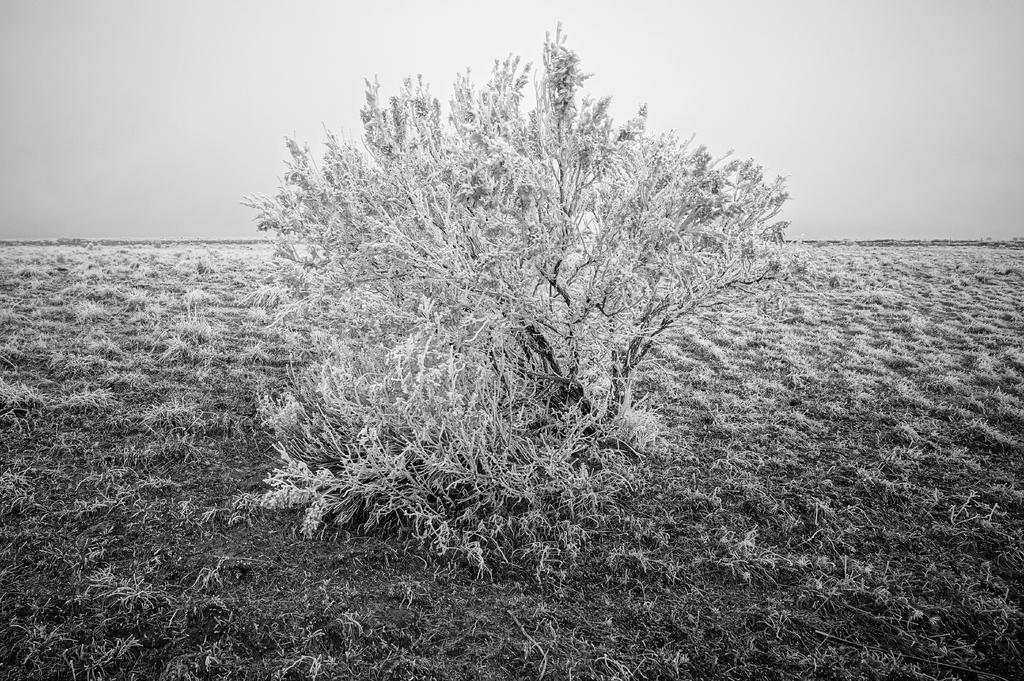Could you give a brief overview of what you see in this image? This image is a black and white image. This image is taken outdoors. At the top of the image there is the sky. At the bottom of the image there is ground with grass on it. In the middle of the image there is a tree with branches, stems and leaves. 